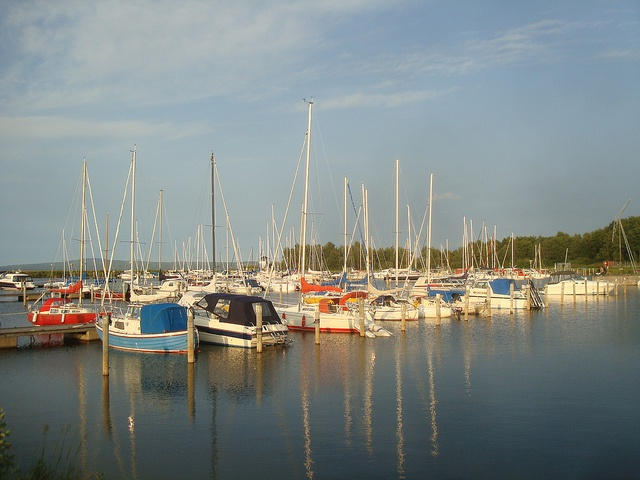Describe the objects in this image and their specific colors. I can see boat in gray and tan tones, boat in gray, black, khaki, and tan tones, boat in gray, teal, blue, and khaki tones, boat in gray, khaki, and tan tones, and boat in gray, brown, and khaki tones in this image. 